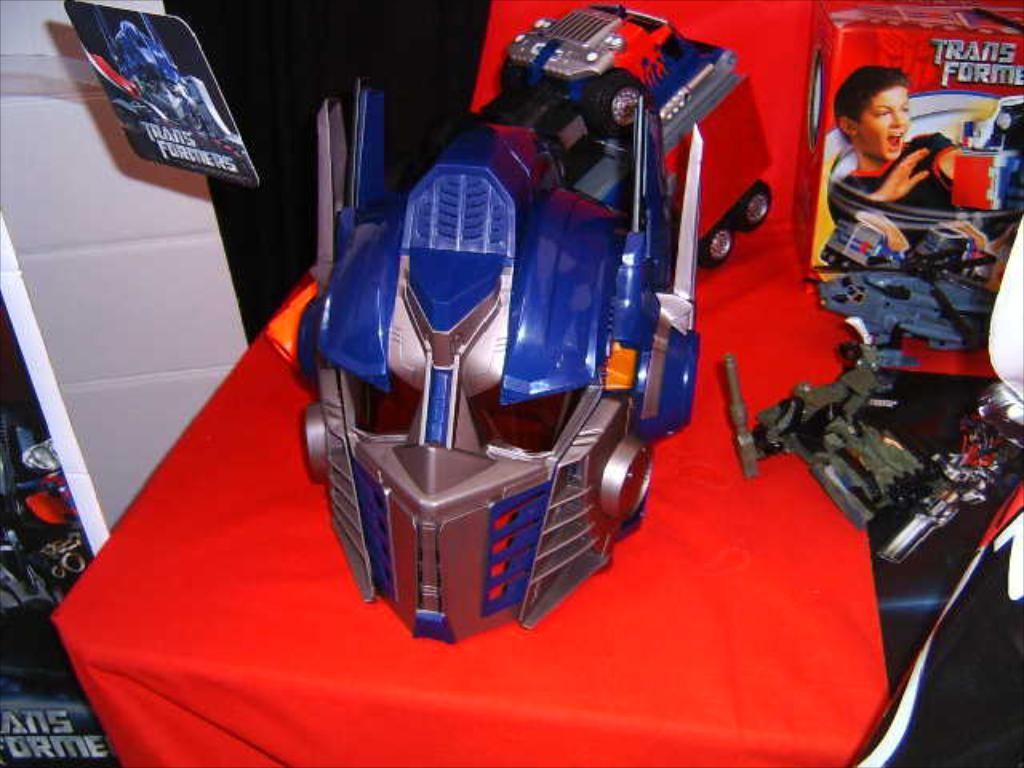What is the main subject of the image? The main subject of the image is toys. How many toys can be seen in the image? There are three toys visible in the image, one on the table in the center and one on each side. Can you describe the position of the toys in the image? Yes, there is a toy placed on the table in the center of the image, and there is a toy on the right side and a toy on the left side of the image. What type of sheet is covering the toys in the image? There is no sheet covering the toys in the image; they are visible and not obstructed. 